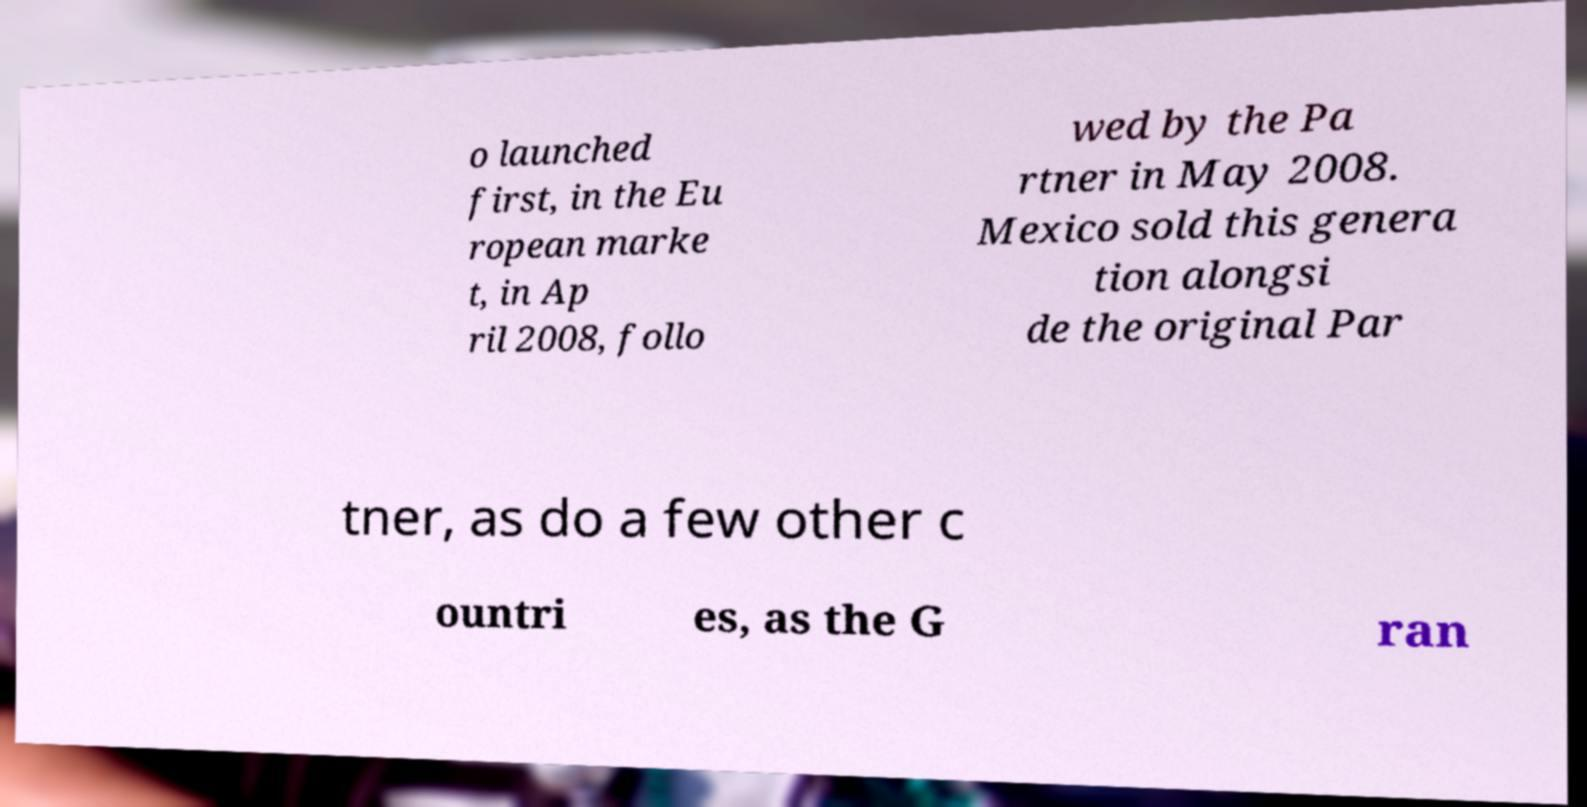I need the written content from this picture converted into text. Can you do that? o launched first, in the Eu ropean marke t, in Ap ril 2008, follo wed by the Pa rtner in May 2008. Mexico sold this genera tion alongsi de the original Par tner, as do a few other c ountri es, as the G ran 